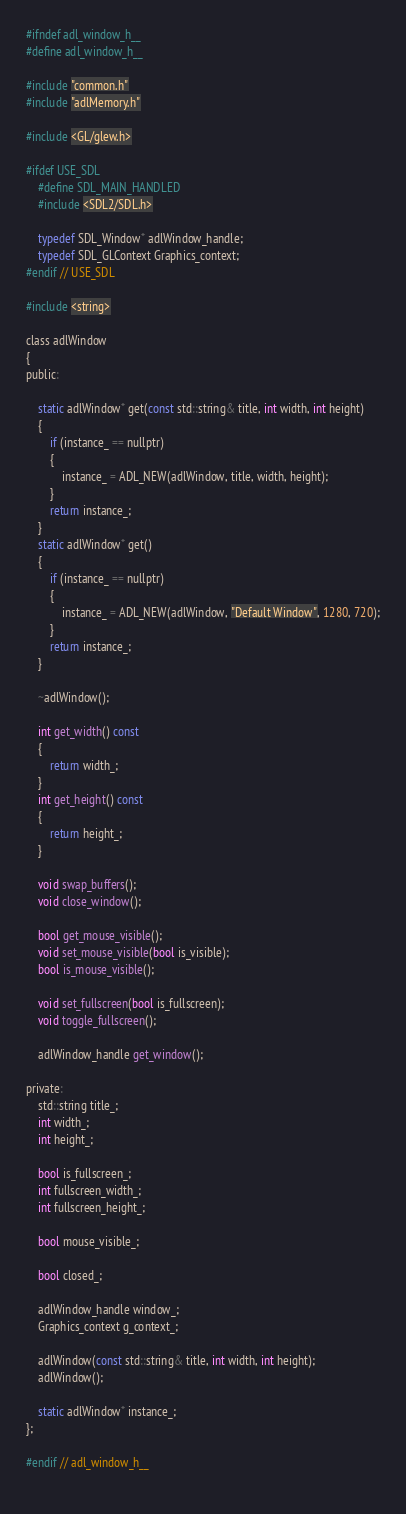Convert code to text. <code><loc_0><loc_0><loc_500><loc_500><_C_>#ifndef adl_window_h__
#define adl_window_h__

#include "common.h"
#include "adlMemory.h"

#include <GL/glew.h>

#ifdef USE_SDL
	#define SDL_MAIN_HANDLED
	#include <SDL2/SDL.h>

	typedef SDL_Window* adlWindow_handle;
	typedef SDL_GLContext Graphics_context;
#endif // USE_SDL

#include <string>

class adlWindow
{
public:

	static adlWindow* get(const std::string& title, int width, int height)
	{
		if (instance_ == nullptr)
		{
			instance_ = ADL_NEW(adlWindow, title, width, height);
		}
		return instance_;
	}
	static adlWindow* get()
	{
		if (instance_ == nullptr)
		{
			instance_ = ADL_NEW(adlWindow, "Default Window", 1280, 720);
		}
		return instance_;
	}

	~adlWindow();

	int get_width() const
	{
		return width_;
	}
	int get_height() const
	{
		return height_;
	}

	void swap_buffers();
	void close_window();

	bool get_mouse_visible();
	void set_mouse_visible(bool is_visible);
	bool is_mouse_visible();

	void set_fullscreen(bool is_fullscreen);
	void toggle_fullscreen();

	adlWindow_handle get_window();

private:
	std::string title_;
	int width_;
	int height_;

	bool is_fullscreen_;
	int fullscreen_width_;
	int fullscreen_height_;

	bool mouse_visible_;

	bool closed_;

	adlWindow_handle window_;
	Graphics_context g_context_;

	adlWindow(const std::string& title, int width, int height);
	adlWindow();

	static adlWindow* instance_;
};

#endif // adl_window_h__
 
</code> 